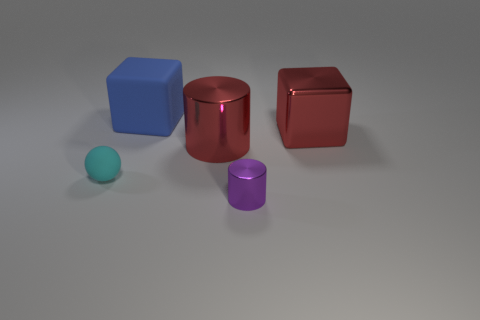Add 1 tiny things. How many objects exist? 6 Subtract all cylinders. How many objects are left? 3 Add 1 red things. How many red things exist? 3 Subtract 0 gray balls. How many objects are left? 5 Subtract all big red metal cylinders. Subtract all large brown metallic objects. How many objects are left? 4 Add 5 purple shiny objects. How many purple shiny objects are left? 6 